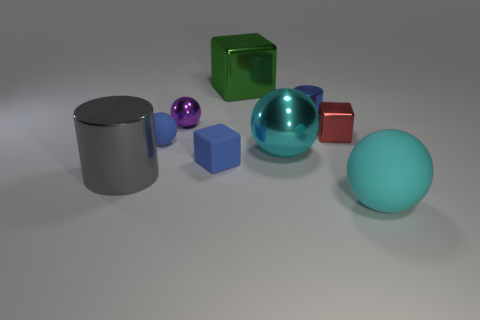What materials are the objects in the image made of? The objects appear to simulate different materials common in computer graphics. The two spheres and the cylinder look like they have a shiny, reflective surface, indicative of a metallic or glass-like material. The cube and small rounded cube seem matte, similar to plastic or rubber. Additionally, one sphere has a more translucent appearance, which might suggest a transparent or semi-transparent material like glass or acrylic. 